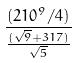<formula> <loc_0><loc_0><loc_500><loc_500>\frac { ( 2 1 0 ^ { 9 } / 4 ) } { \frac { ( \sqrt { 9 } + 3 1 7 ) } { \sqrt { 5 } } }</formula> 